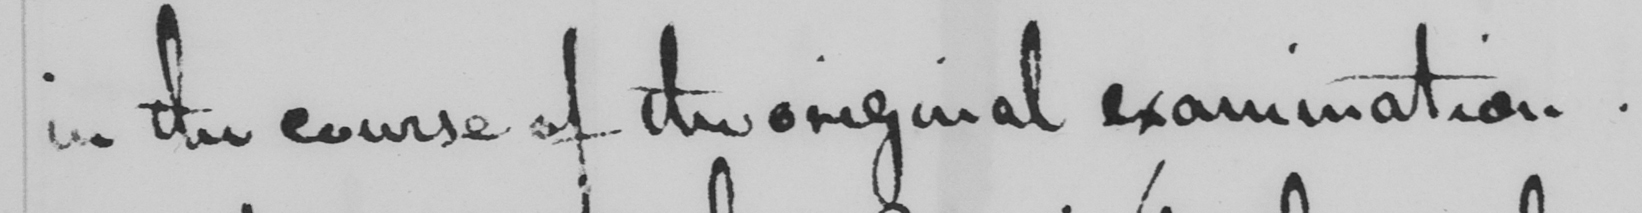What text is written in this handwritten line? in the course of the original examination. 